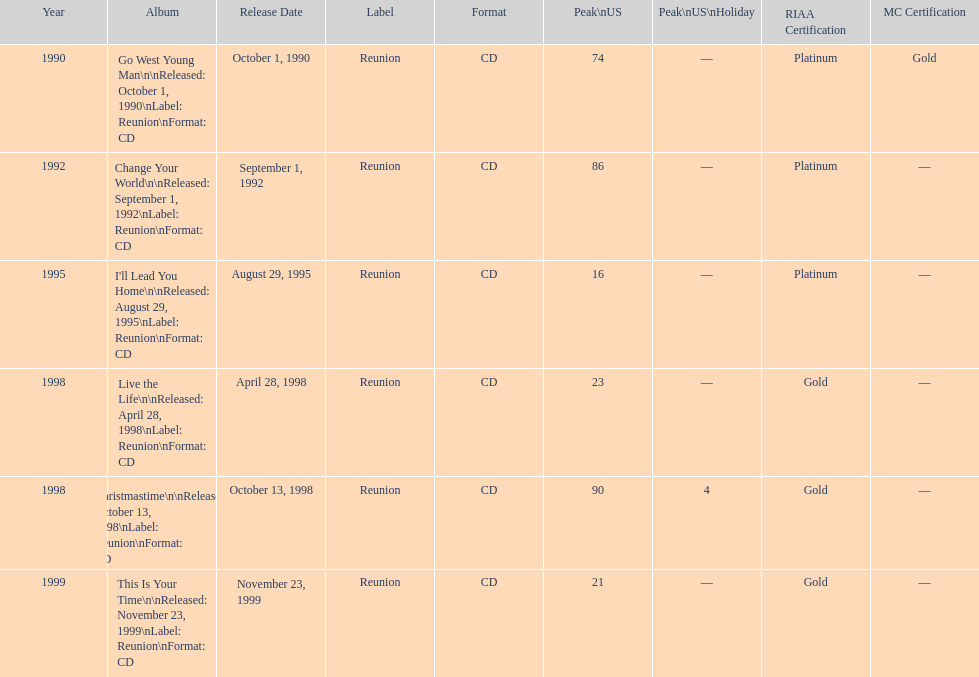What michael w smith album was released before his christmastime album? Live the Life. 